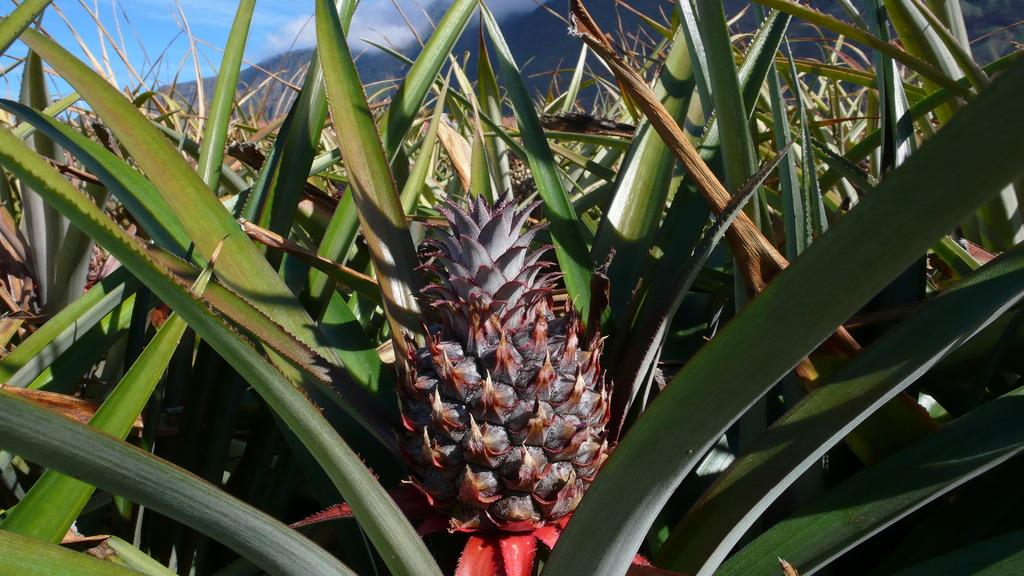What type of plants can be seen in the image? There is a field of pineapple in the image. What is visible at the top of the image? The sky is visible at the top of the image. What can be seen in the sky? Clouds are present in the sky. How many feet are visible in the image? There are no feet present in the image; it features a field of pineapple and a sky with clouds. What type of trick can be seen being performed with the pineapples in the image? There is no trick being performed with the pineapples in the image; it is a field of pineapple plants. 